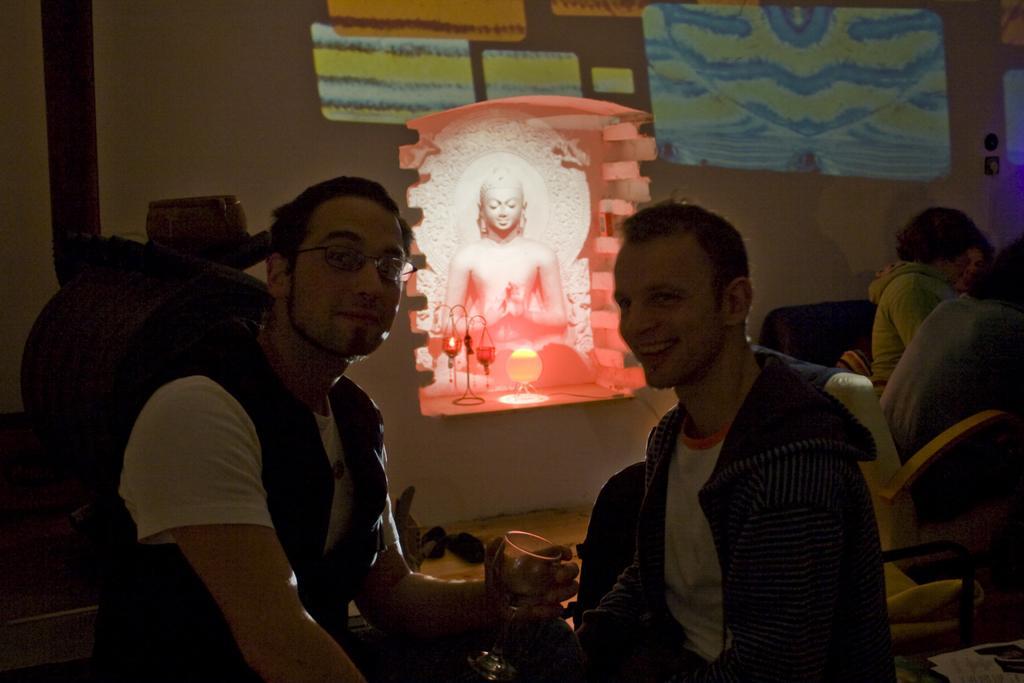Can you describe this image briefly? In this picture we can see a group of people sitting on chairs where a man holding a glass with his hand and smiling and in the background we can see a wall, statue. 